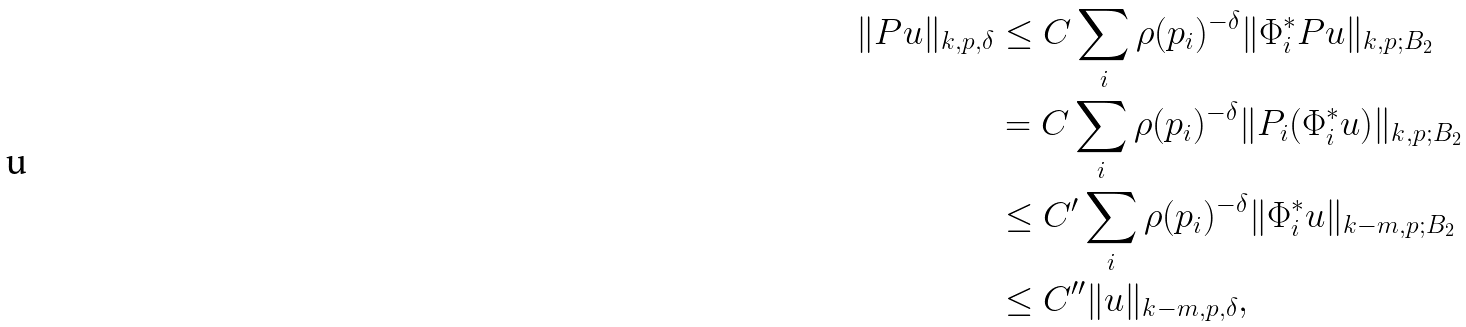Convert formula to latex. <formula><loc_0><loc_0><loc_500><loc_500>\| P u \| _ { k , p , \delta } & \leq C \sum _ { i } \rho ( p _ { i } ) ^ { - \delta } \| \Phi _ { i } ^ { * } P u \| _ { k , p ; B _ { 2 } } \\ & = C \sum _ { i } \rho ( p _ { i } ) ^ { - \delta } \| P _ { i } ( \Phi _ { i } ^ { * } u ) \| _ { k , p ; B _ { 2 } } \\ & \leq C ^ { \prime } \sum _ { i } \rho ( p _ { i } ) ^ { - \delta } \| \Phi _ { i } ^ { * } u \| _ { k - m , p ; B _ { 2 } } \\ & \leq C ^ { \prime \prime } \| u \| _ { k - m , p , \delta } ,</formula> 